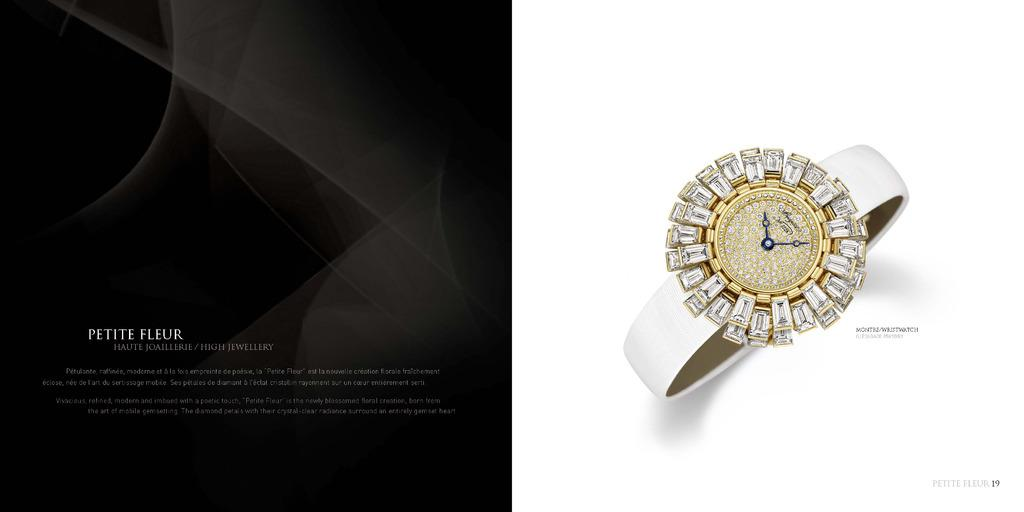<image>
Present a compact description of the photo's key features. An elegant watch encircled with jewels is pictured in a Petite Fleur brochure. 